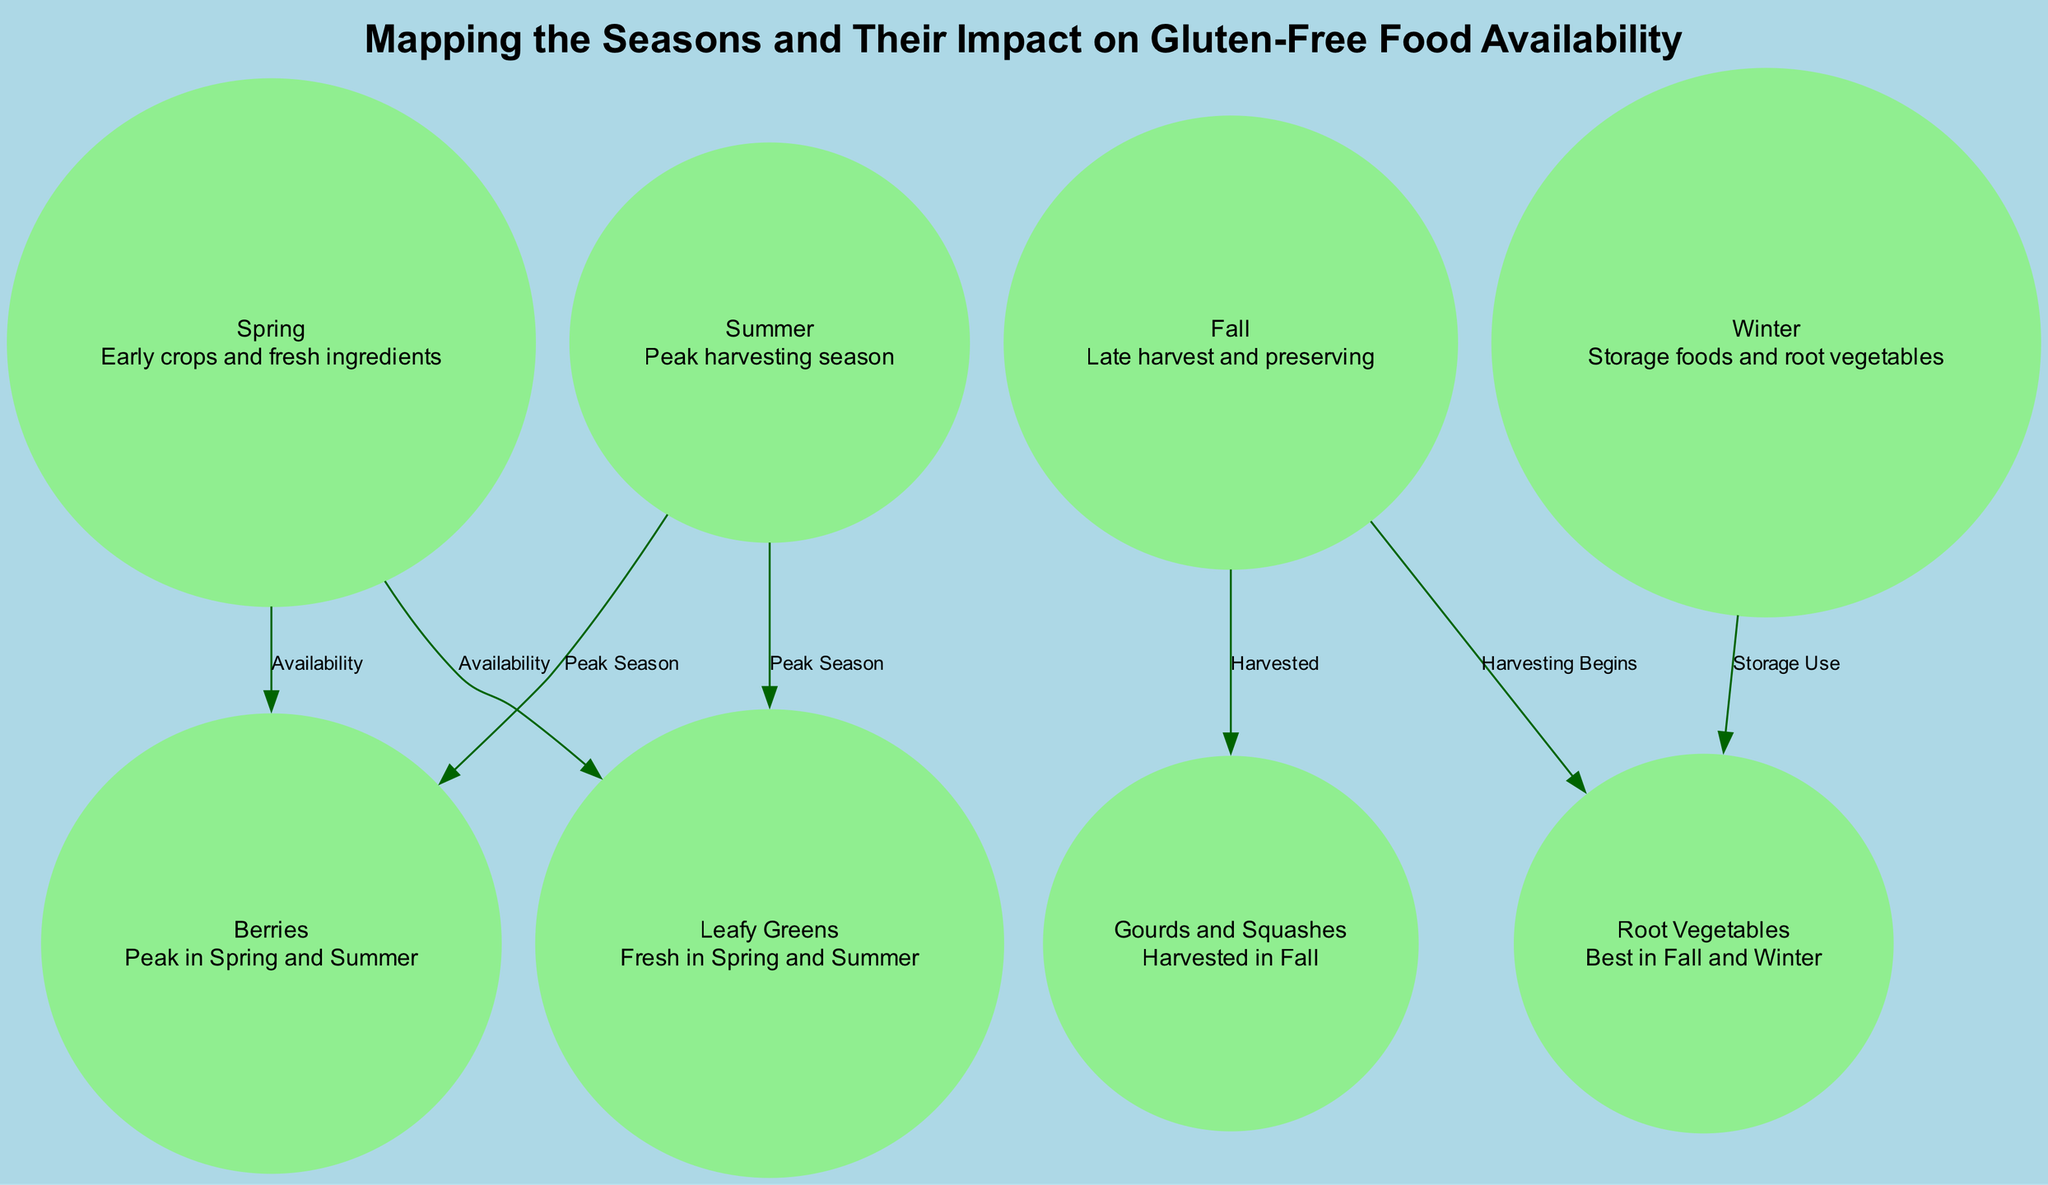What is the peak season for Berries? According to the diagram, Berries are in their peak season during both Spring and Summer, as indicated by the edges connecting those seasons to the Berries node.
Answer: Spring and Summer Which vegetables are best harvested in Fall? The diagram states that Root Vegetables and Gourds and Squashes are harvested in Fall. Root Vegetables begin their harvesting in Fall, while Gourds and Squashes are fully harvested then.
Answer: Root Vegetables and Gourds and Squashes How many seasons are represented in the diagram? The diagram shows four distinct seasons: Spring, Summer, Fall, and Winter. Each season is a separate node in the diagram.
Answer: Four What foods are associated with Winter? The diagram indicates that Root Vegetables are primarily associated with Winter under the description "Storage Use," implying that these are the foods available during that season.
Answer: Root Vegetables What type of food is available early in the Spring? The description under the Spring node states "Early crops and fresh ingredients," which encompasses foods like Berries and Leafy Greens that are readily available during this season.
Answer: Early crops and fresh ingredients How many total edges are present in the diagram? By counting the connections (edges) in the diagram, we find there are seven edges indicating relationships between seasons and food availability.
Answer: Seven Which season primarily focuses on preserving food? The Fall season is described as a time for late harvest and preserving, as noted in its description node, indicating that it focuses on preserving food harvested during this time.
Answer: Fall What are the two types of foods associated with the Spring season? According to the edges stemming from the Spring node, both Berries and Leafy Greens are associated with Spring, reflecting their availability during this season.
Answer: Berries and Leafy Greens 